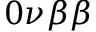Convert formula to latex. <formula><loc_0><loc_0><loc_500><loc_500>0 \nu \beta \beta</formula> 